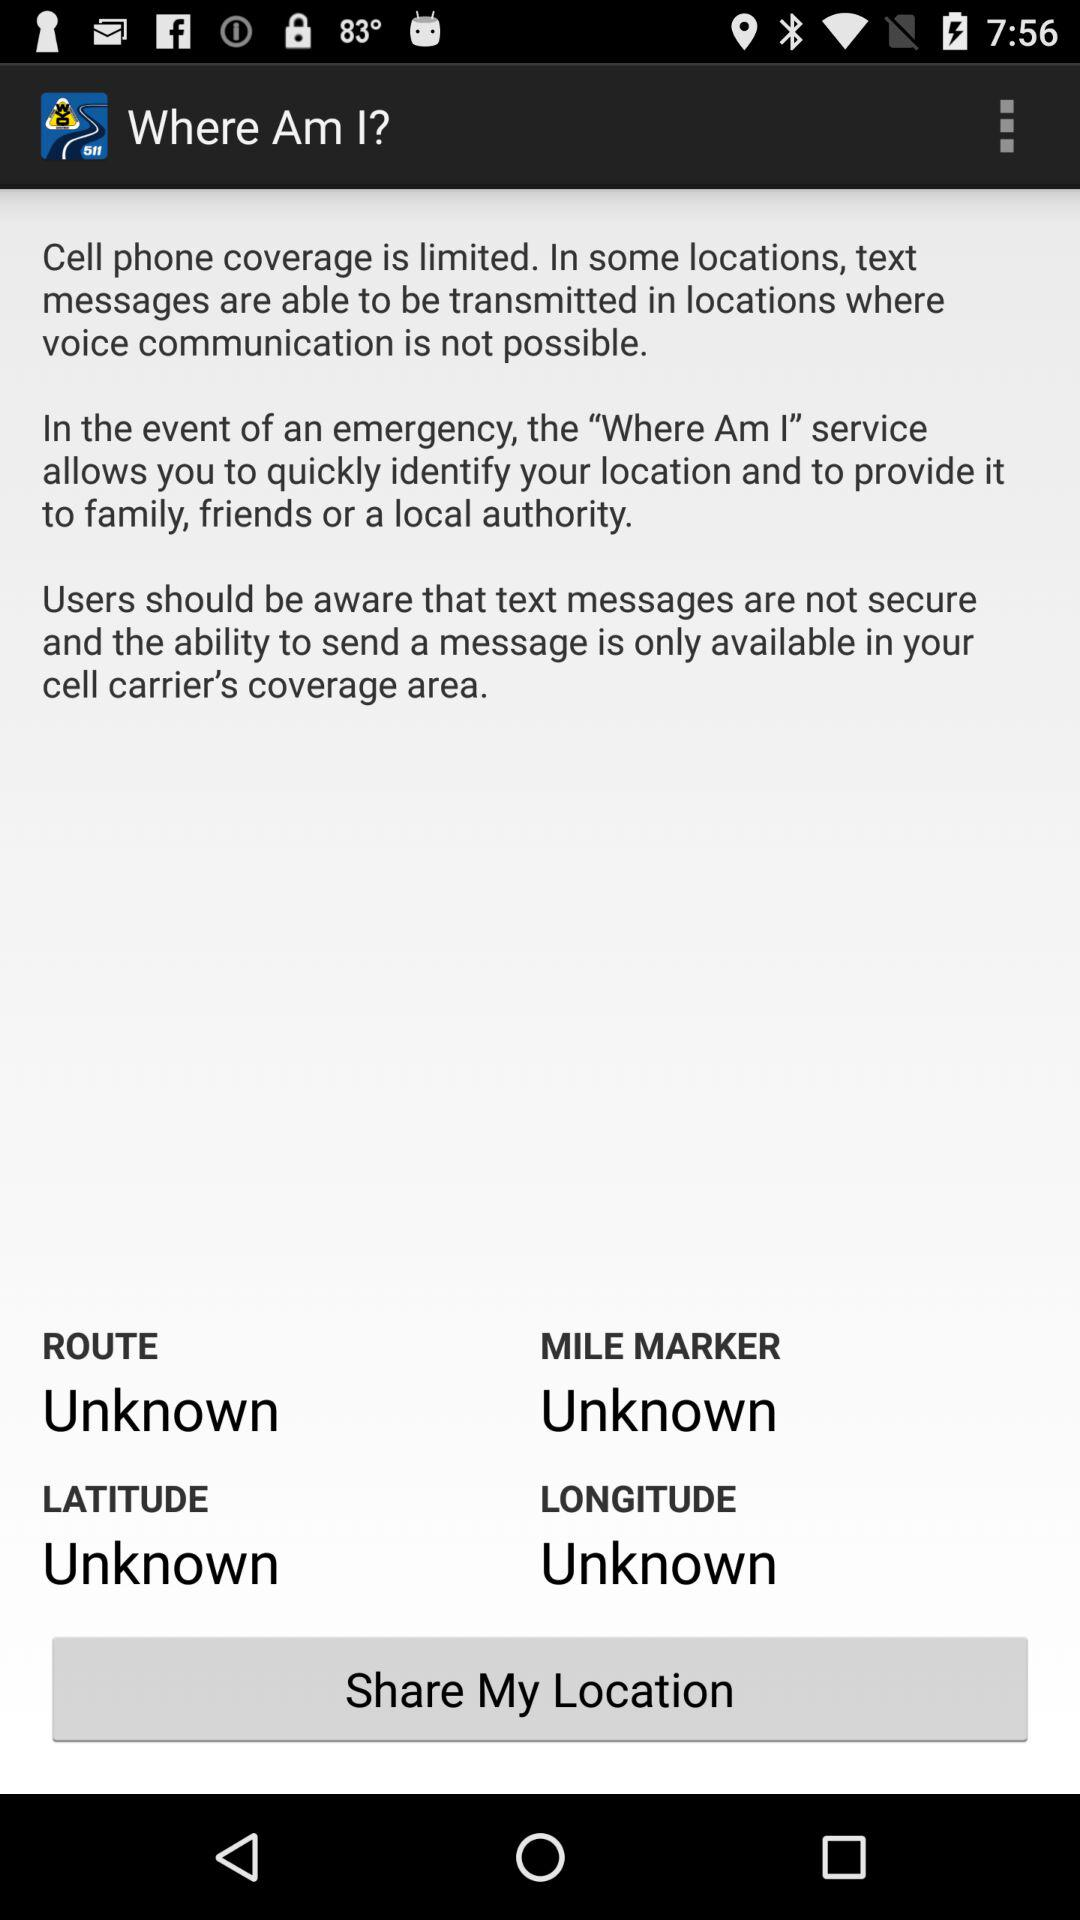What is the app name? The app name is "Where Am I?". 